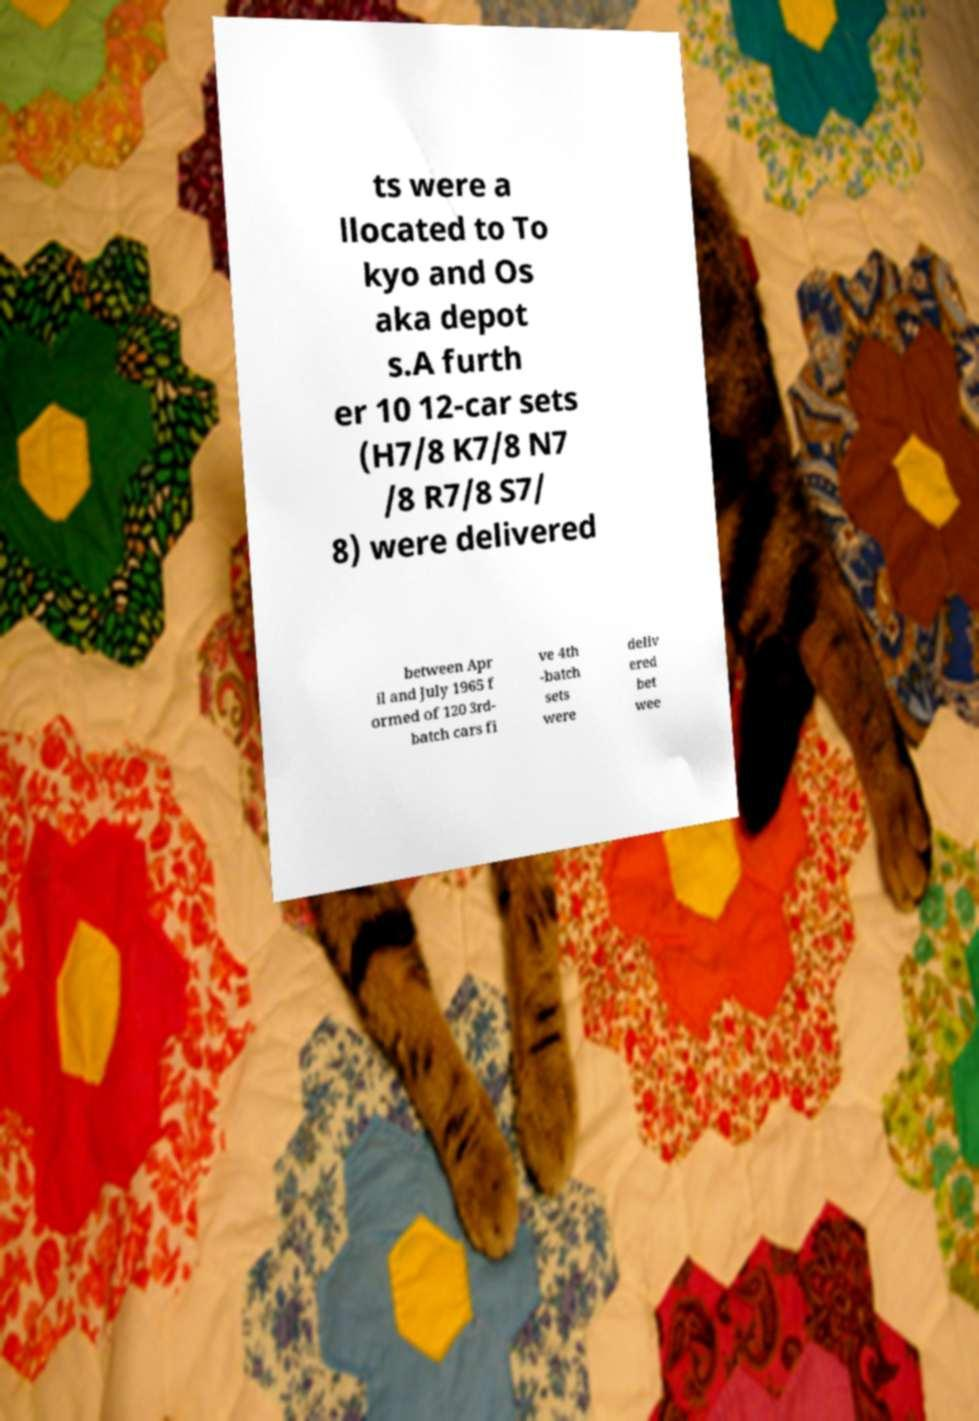Could you extract and type out the text from this image? ts were a llocated to To kyo and Os aka depot s.A furth er 10 12-car sets (H7/8 K7/8 N7 /8 R7/8 S7/ 8) were delivered between Apr il and July 1965 f ormed of 120 3rd- batch cars fi ve 4th -batch sets were deliv ered bet wee 